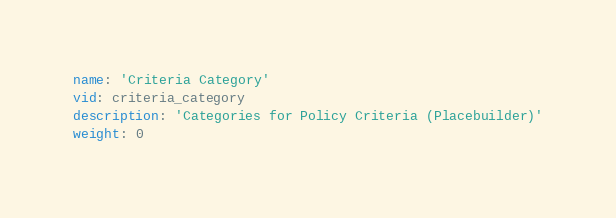<code> <loc_0><loc_0><loc_500><loc_500><_YAML_>name: 'Criteria Category'
vid: criteria_category
description: 'Categories for Policy Criteria (Placebuilder)'
weight: 0
</code> 